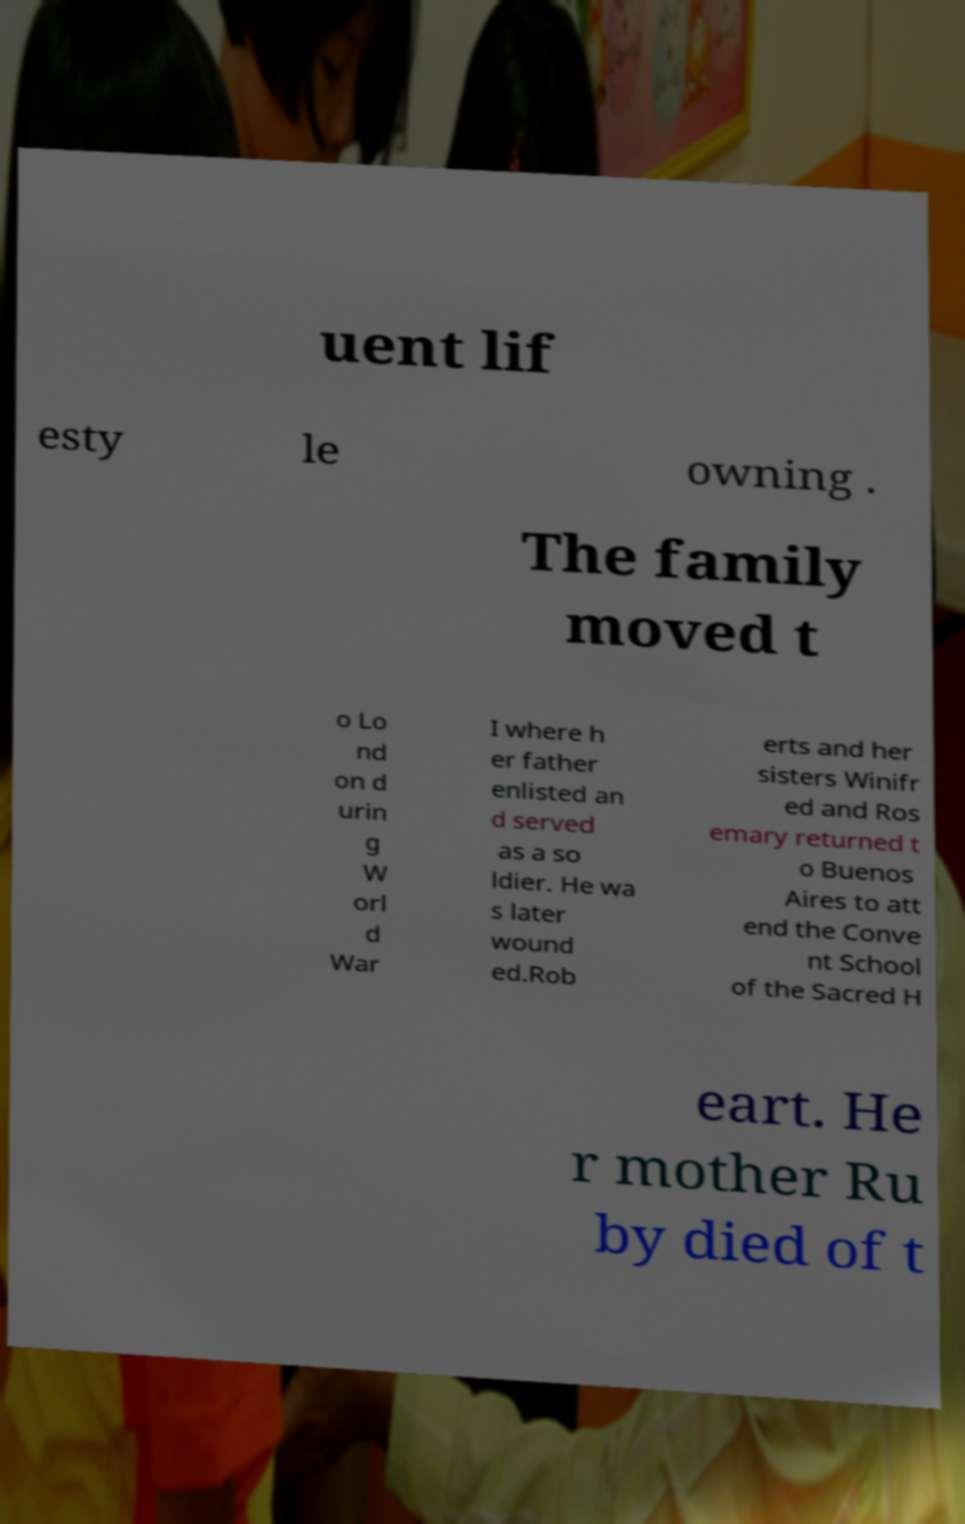Can you accurately transcribe the text from the provided image for me? uent lif esty le owning . The family moved t o Lo nd on d urin g W orl d War I where h er father enlisted an d served as a so ldier. He wa s later wound ed.Rob erts and her sisters Winifr ed and Ros emary returned t o Buenos Aires to att end the Conve nt School of the Sacred H eart. He r mother Ru by died of t 